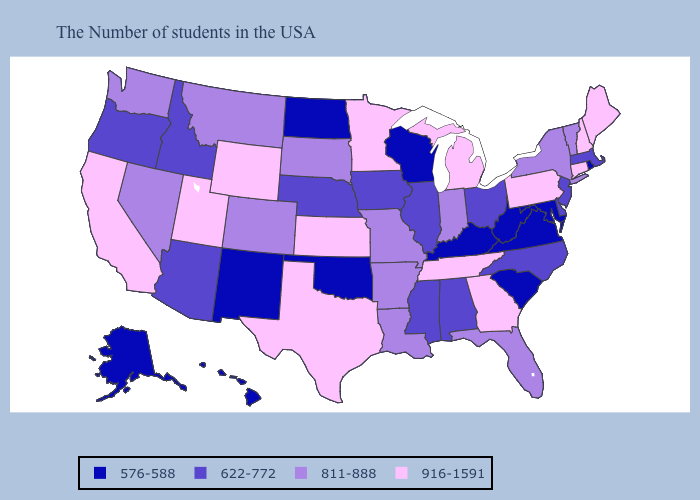How many symbols are there in the legend?
Give a very brief answer. 4. Does the map have missing data?
Give a very brief answer. No. Does Wyoming have the lowest value in the West?
Short answer required. No. Which states have the lowest value in the Northeast?
Answer briefly. Rhode Island. What is the highest value in the MidWest ?
Quick response, please. 916-1591. What is the value of New Mexico?
Concise answer only. 576-588. What is the value of Michigan?
Answer briefly. 916-1591. Does Georgia have the highest value in the USA?
Keep it brief. Yes. Does Tennessee have the same value as Georgia?
Concise answer only. Yes. Does South Carolina have the lowest value in the USA?
Quick response, please. Yes. Which states have the lowest value in the USA?
Write a very short answer. Rhode Island, Maryland, Virginia, South Carolina, West Virginia, Kentucky, Wisconsin, Oklahoma, North Dakota, New Mexico, Alaska, Hawaii. Does Maryland have the same value as Alaska?
Be succinct. Yes. Does Nebraska have a lower value than North Carolina?
Be succinct. No. What is the value of Georgia?
Quick response, please. 916-1591. What is the value of South Carolina?
Short answer required. 576-588. 